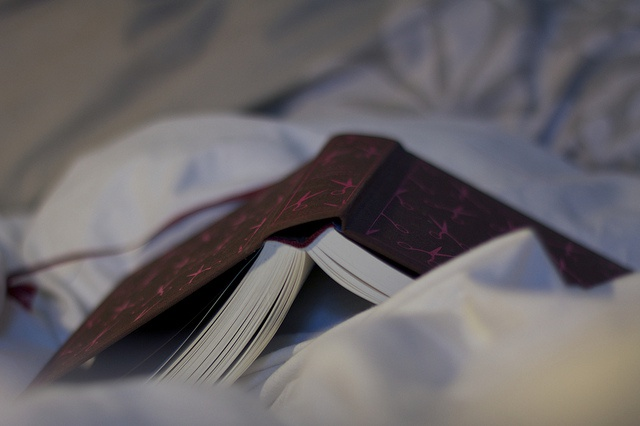Describe the objects in this image and their specific colors. I can see bed in gray, darkgray, and black tones and book in black, darkgray, and gray tones in this image. 